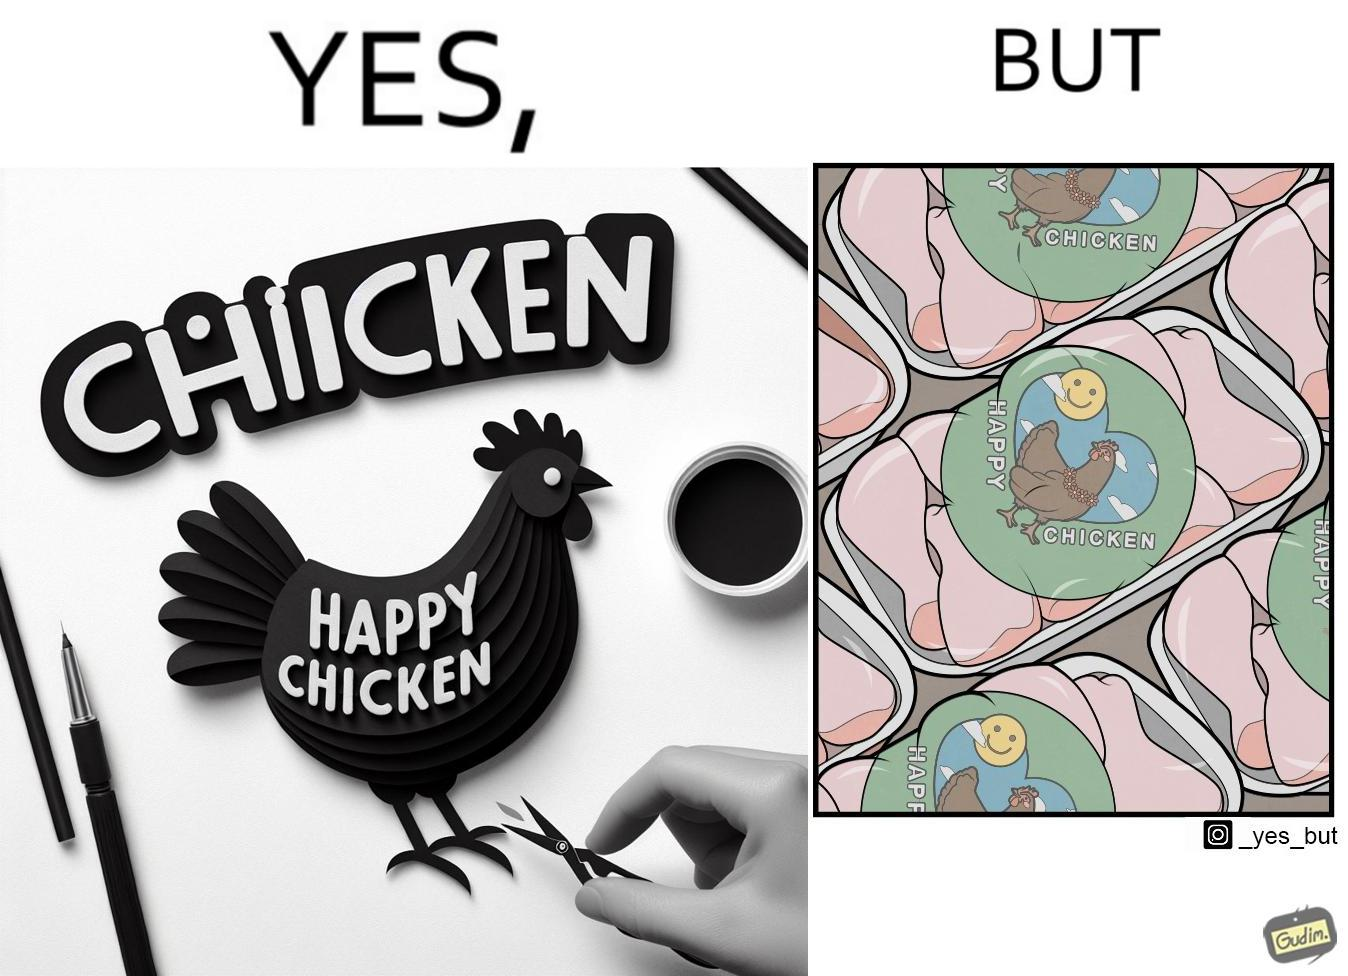What is shown in this image? The image is ironic, because in the left image as in the logo it shows happy chicken but in the right image the chicken pieces are shown packed in boxes 